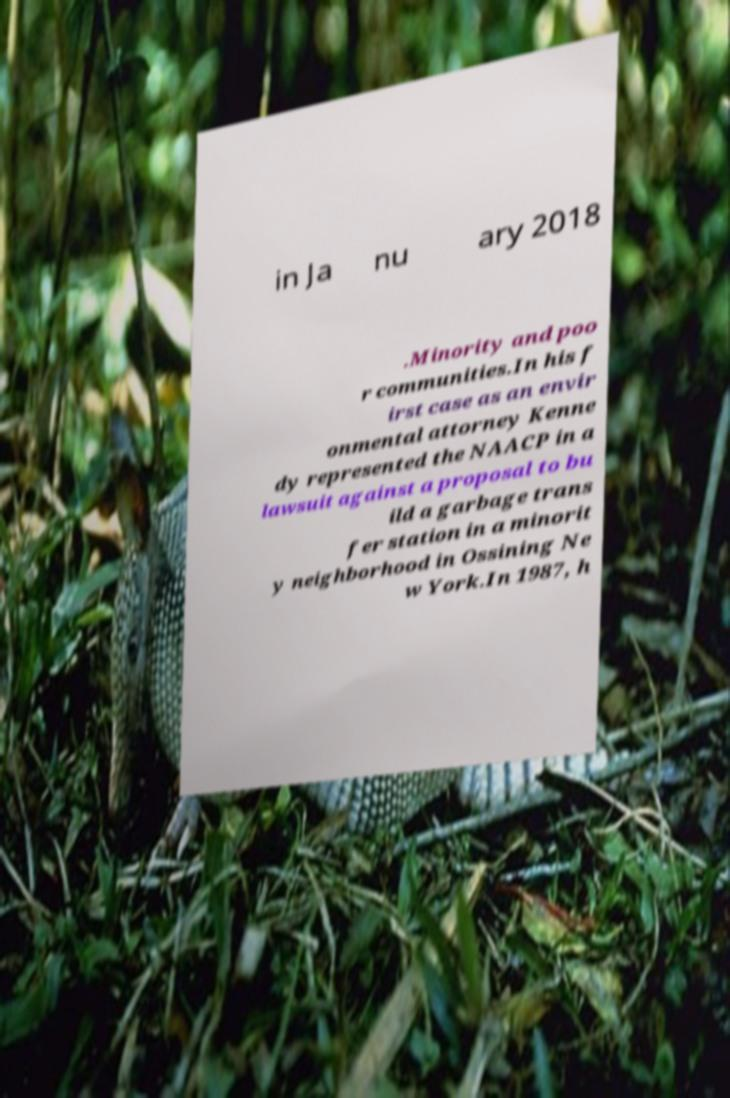There's text embedded in this image that I need extracted. Can you transcribe it verbatim? in Ja nu ary 2018 .Minority and poo r communities.In his f irst case as an envir onmental attorney Kenne dy represented the NAACP in a lawsuit against a proposal to bu ild a garbage trans fer station in a minorit y neighborhood in Ossining Ne w York.In 1987, h 